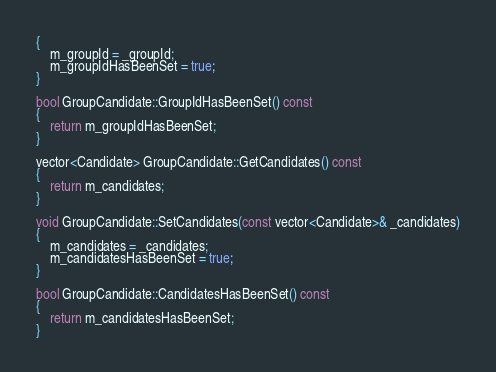<code> <loc_0><loc_0><loc_500><loc_500><_C++_>{
    m_groupId = _groupId;
    m_groupIdHasBeenSet = true;
}

bool GroupCandidate::GroupIdHasBeenSet() const
{
    return m_groupIdHasBeenSet;
}

vector<Candidate> GroupCandidate::GetCandidates() const
{
    return m_candidates;
}

void GroupCandidate::SetCandidates(const vector<Candidate>& _candidates)
{
    m_candidates = _candidates;
    m_candidatesHasBeenSet = true;
}

bool GroupCandidate::CandidatesHasBeenSet() const
{
    return m_candidatesHasBeenSet;
}

</code> 